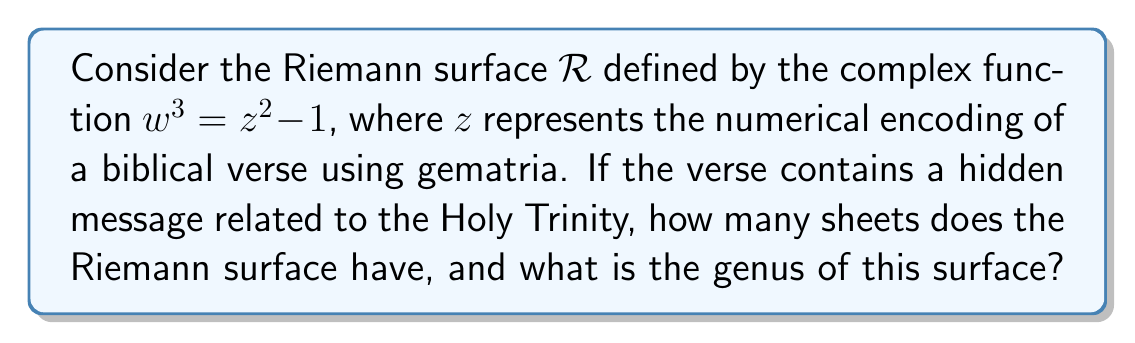Teach me how to tackle this problem. To solve this problem, we need to analyze the Riemann surface defined by the given equation:

$$w^3 = z^2 - 1$$

1. Number of sheets:
   The number of sheets in a Riemann surface is determined by the highest degree of the variable we're solving for. In this case, we're solving for $w$, which has a degree of 3. Therefore, the Riemann surface has 3 sheets.

2. Branch points:
   Branch points occur where the derivative of the function with respect to $z$ is zero or undefined. Let's find these points:
   
   $$\frac{d}{dz}(z^2 - 1) = 2z$$
   
   Setting this to zero: $2z = 0$, so $z = 0$.
   
   Additionally, we have branch points at $z = \pm 1$ because $w = 0$ at these points, creating singularities.

3. Genus calculation:
   To calculate the genus, we use the Riemann-Hurwitz formula:

   $$2g - 2 = n(2G - 2) + B$$

   Where:
   $g$ is the genus of the Riemann surface
   $G$ is the genus of the base surface (which is 0 for the complex plane)
   $n$ is the number of sheets (3 in this case)
   $B$ is the total branching order

   We have 3 branch points (at $z = 0, \pm 1$), each with order 2 (because 3 sheets come together at each point). So, $B = 3 \times 2 = 6$.

   Plugging into the formula:

   $$2g - 2 = 3(2 \cdot 0 - 2) + 6$$
   $$2g - 2 = -6 + 6 = 0$$
   $$2g = 2$$
   $$g = 1$$

Thus, the genus of the Riemann surface is 1.
Answer: The Riemann surface has 3 sheets and a genus of 1. 